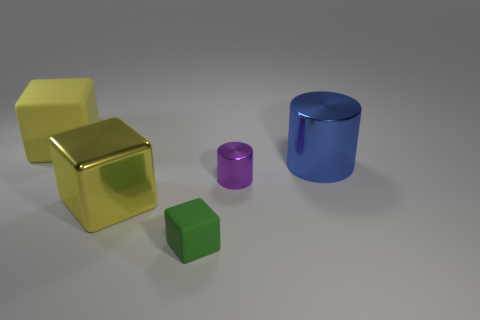Add 3 blue objects. How many objects exist? 8 Subtract all cubes. How many objects are left? 2 Add 3 rubber objects. How many rubber objects are left? 5 Add 2 purple cubes. How many purple cubes exist? 2 Subtract 0 yellow cylinders. How many objects are left? 5 Subtract all big yellow blocks. Subtract all large blocks. How many objects are left? 1 